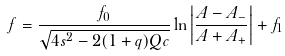<formula> <loc_0><loc_0><loc_500><loc_500>f = \frac { f _ { 0 } } { \sqrt { 4 s ^ { 2 } - 2 ( 1 + q ) Q c } } \ln { \left | \frac { A - A _ { - } } { A + A _ { + } } \right | } + f _ { 1 }</formula> 